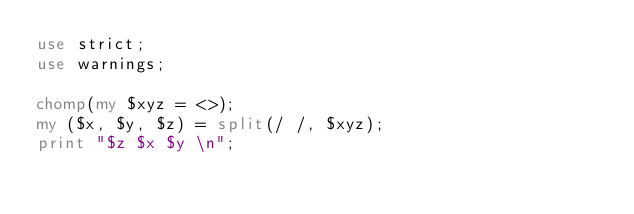Convert code to text. <code><loc_0><loc_0><loc_500><loc_500><_Perl_>use strict;
use warnings;

chomp(my $xyz = <>);
my ($x, $y, $z) = split(/ /, $xyz);
print "$z $x $y \n";

</code> 